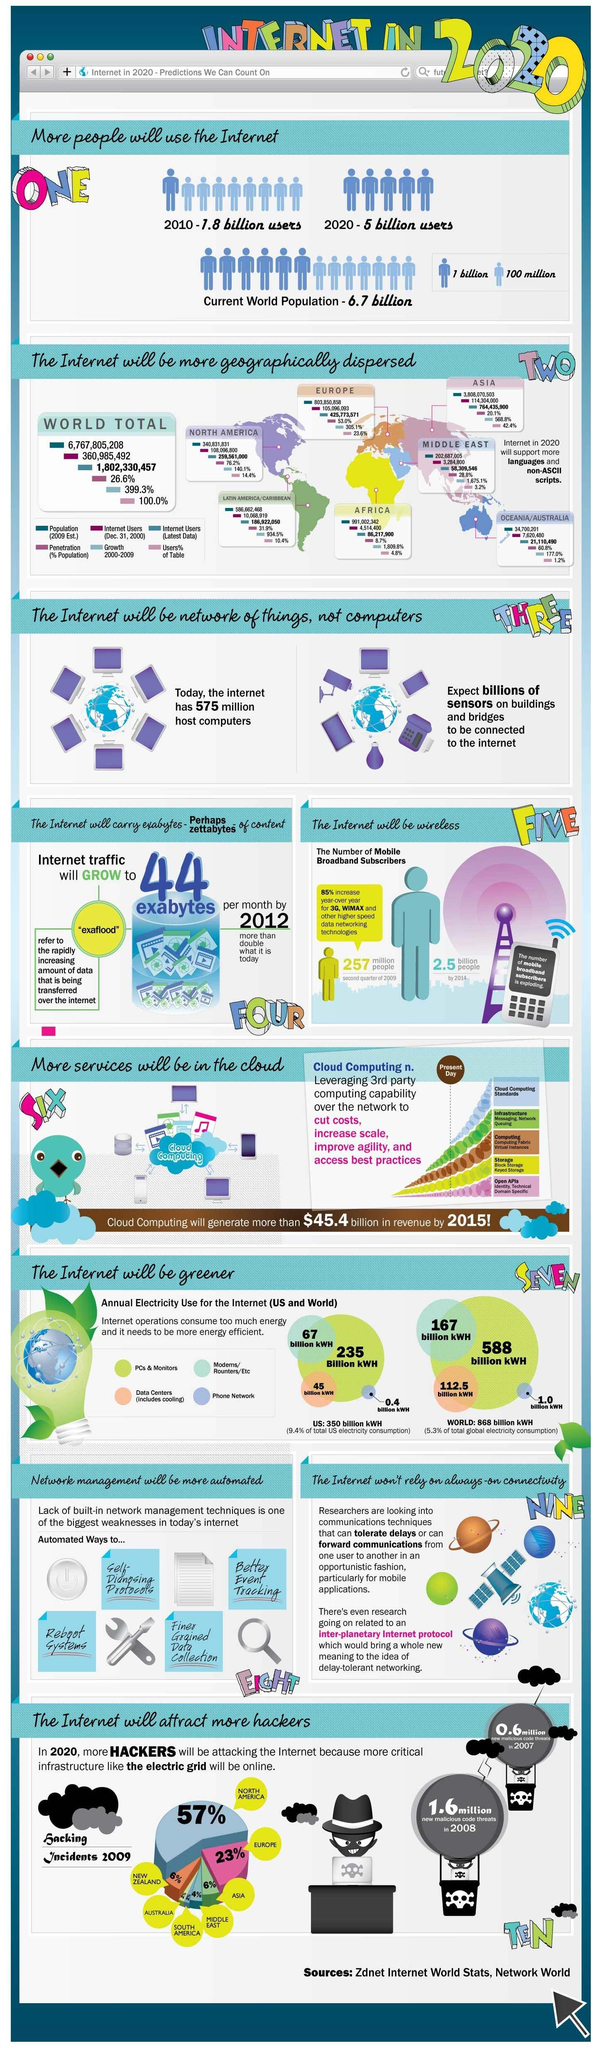By what number has internet users increased from 2010 to 2020?
Answer the question with a short phrase. 3.2 billion users By what number did new malicious code threats increase from 2007 to 2008? 1.0 million Which country has the most number of hacking incidents? NORTH AMERICA 